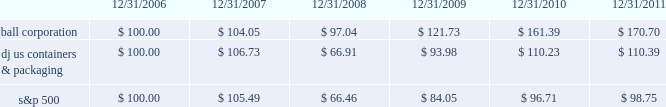Shareholder return performance the line graph below compares the annual percentage change in ball corporation fffds cumulative total shareholder return on its common stock with the cumulative total return of the dow jones containers & packaging index and the s&p composite 500 stock index for the five-year period ended december 31 , 2011 .
It assumes $ 100 was invested on december 31 , 2006 , and that all dividends were reinvested .
The dow jones containers & packaging index total return has been weighted by market capitalization .
Total return to stockholders ( assumes $ 100 investment on 12/31/06 ) total return analysis .
Copyright a9 2012 standard & poor fffds , a division of the mcgraw-hill companies inc .
All rights reserved .
( www.researchdatagroup.com/s&p.htm ) copyright a9 2012 dow jones & company .
All rights reserved. .
What is the roi of an investment in ball corporation from 2006 to 2008? 
Computations: ((97.04 - 100) / 100)
Answer: -0.0296. 